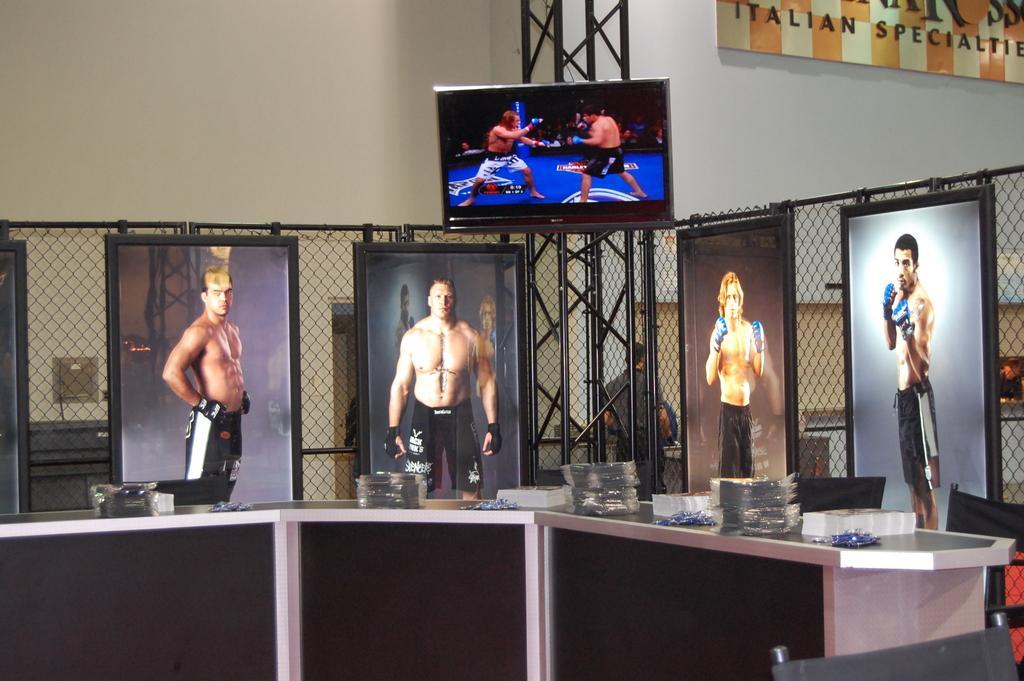Can you describe this image briefly? In this picture I can see few photo frames and a table and few items on the table and I can see a television and a board with some text and I can see a man standing in the back. 